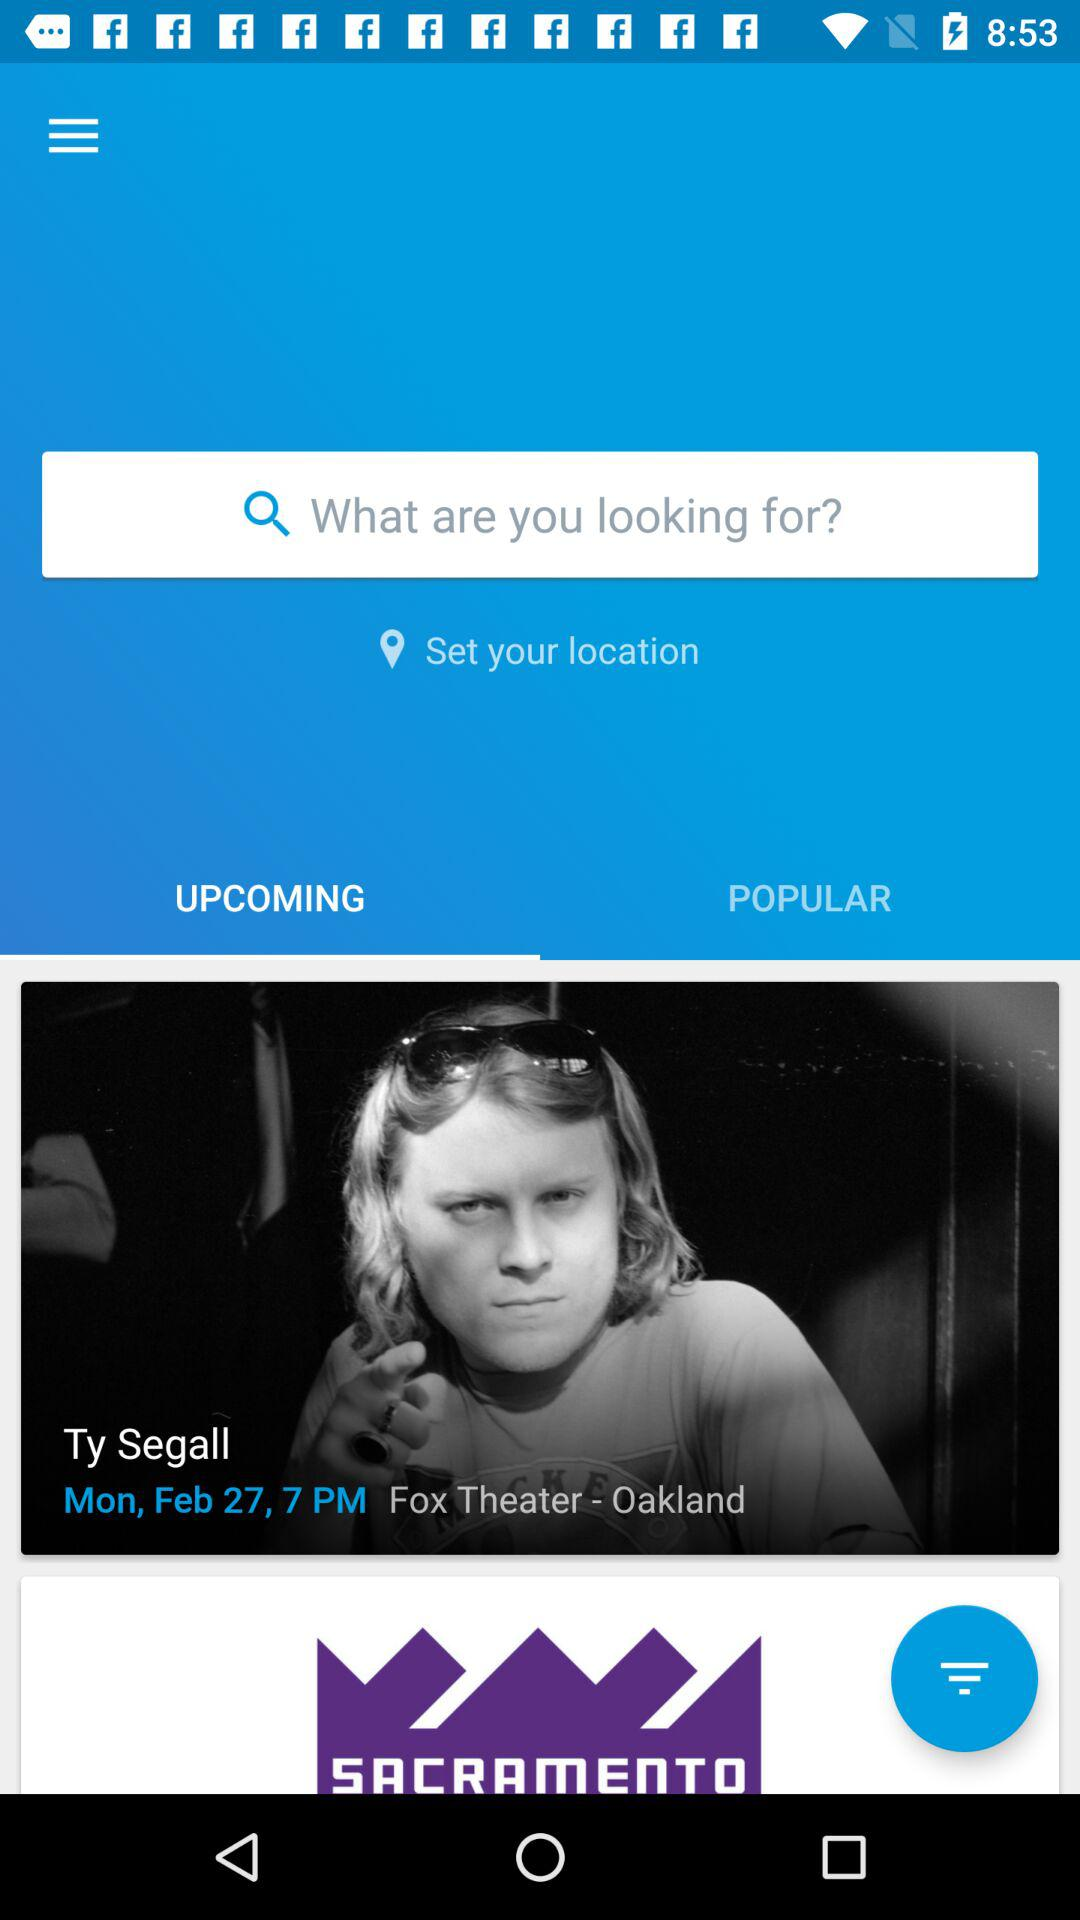What is the title of the upcoming movie? The title is "Ty Segall". 